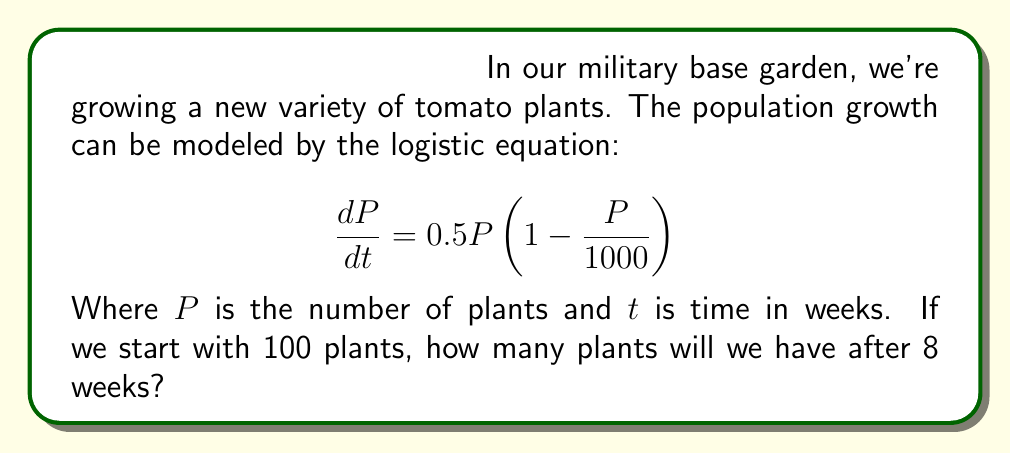Could you help me with this problem? Let's approach this step-by-step:

1) The given logistic equation is:
   $$\frac{dP}{dt} = 0.5P(1 - \frac{P}{1000})$$

2) The solution to this logistic equation is:
   $$P(t) = \frac{K}{1 + (\frac{K}{P_0} - 1)e^{-rt}}$$

   Where:
   - $K$ is the carrying capacity (1000 in this case)
   - $P_0$ is the initial population (100 plants)
   - $r$ is the growth rate (0.5 in this case)
   - $t$ is the time (8 weeks)

3) Let's substitute these values:
   $$P(8) = \frac{1000}{1 + (\frac{1000}{100} - 1)e^{-0.5(8)}}$$

4) Simplify:
   $$P(8) = \frac{1000}{1 + 9e^{-4}}$$

5) Calculate:
   $$P(8) = \frac{1000}{1 + 9(0.0183)} = \frac{1000}{1.1647}$$

6) This gives us:
   $$P(8) \approx 858.59$$

7) Since we can't have a fraction of a plant, we round down to the nearest whole number.
Answer: 858 plants 